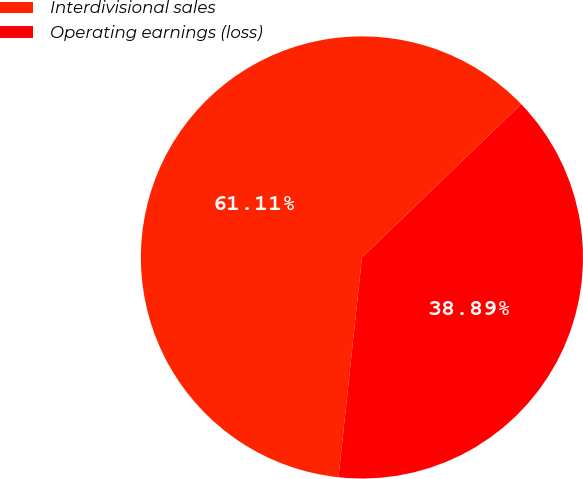Convert chart. <chart><loc_0><loc_0><loc_500><loc_500><pie_chart><fcel>Interdivisional sales<fcel>Operating earnings (loss)<nl><fcel>61.11%<fcel>38.89%<nl></chart> 